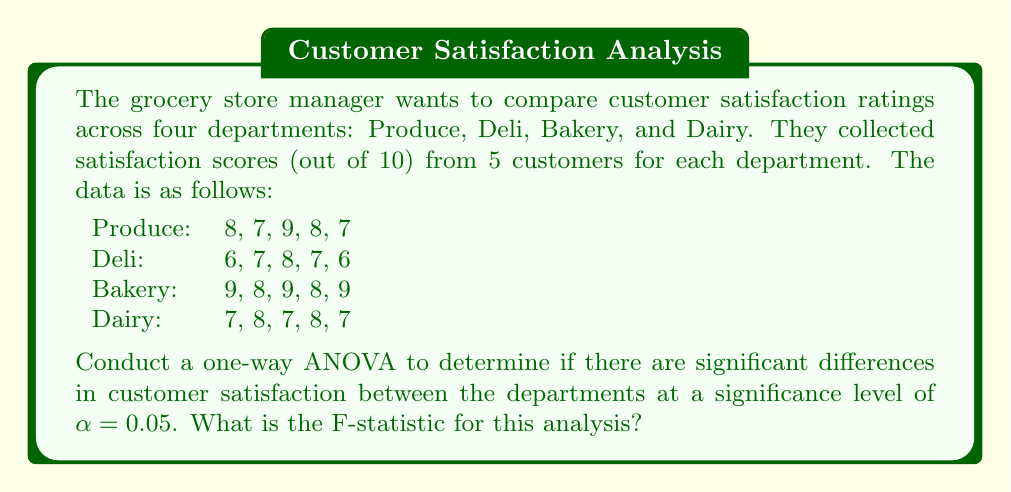Could you help me with this problem? To conduct a one-way ANOVA, we'll follow these steps:

1. Calculate the mean for each group and the overall mean:
   Produce mean: $\bar{X}_P = \frac{8+7+9+8+7}{5} = 7.8$
   Deli mean: $\bar{X}_D = \frac{6+7+8+7+6}{5} = 6.8$
   Bakery mean: $\bar{X}_B = \frac{9+8+9+8+9}{5} = 8.6$
   Dairy mean: $\bar{X}_Y = \frac{7+8+7+8+7}{5} = 7.4$
   Overall mean: $\bar{X} = \frac{7.8+6.8+8.6+7.4}{4} = 7.65$

2. Calculate the Sum of Squares Between groups (SSB):
   $$SSB = \sum_{i=1}^k n_i(\bar{X}_i - \bar{X})^2$$
   $$SSB = 5[(7.8-7.65)^2 + (6.8-7.65)^2 + (8.6-7.65)^2 + (7.4-7.65)^2] = 10.7$$

3. Calculate the Sum of Squares Within groups (SSW):
   $$SSW = \sum_{i=1}^k \sum_{j=1}^{n_i} (X_{ij} - \bar{X}_i)^2$$
   Produce: $(8-7.8)^2 + (7-7.8)^2 + (9-7.8)^2 + (8-7.8)^2 + (7-7.8)^2 = 2.8$
   Deli: $(6-6.8)^2 + (7-6.8)^2 + (8-6.8)^2 + (7-6.8)^2 + (6-6.8)^2 = 2.8$
   Bakery: $(9-8.6)^2 + (8-8.6)^2 + (9-8.6)^2 + (8-8.6)^2 + (9-8.6)^2 = 1.2$
   Dairy: $(7-7.4)^2 + (8-7.4)^2 + (7-7.4)^2 + (8-7.4)^2 + (7-7.4)^2 = 1.2$
   $$SSW = 2.8 + 2.8 + 1.2 + 1.2 = 8$$

4. Calculate degrees of freedom:
   Between groups: $df_B = k - 1 = 4 - 1 = 3$
   Within groups: $df_W = N - k = 20 - 4 = 16$

5. Calculate Mean Square Between (MSB) and Mean Square Within (MSW):
   $$MSB = \frac{SSB}{df_B} = \frac{10.7}{3} = 3.567$$
   $$MSW = \frac{SSW}{df_W} = \frac{8}{16} = 0.5$$

6. Calculate the F-statistic:
   $$F = \frac{MSB}{MSW} = \frac{3.567}{0.5} = 7.134$$

Therefore, the F-statistic for this analysis is 7.134.
Answer: The F-statistic for this one-way ANOVA is 7.134. 